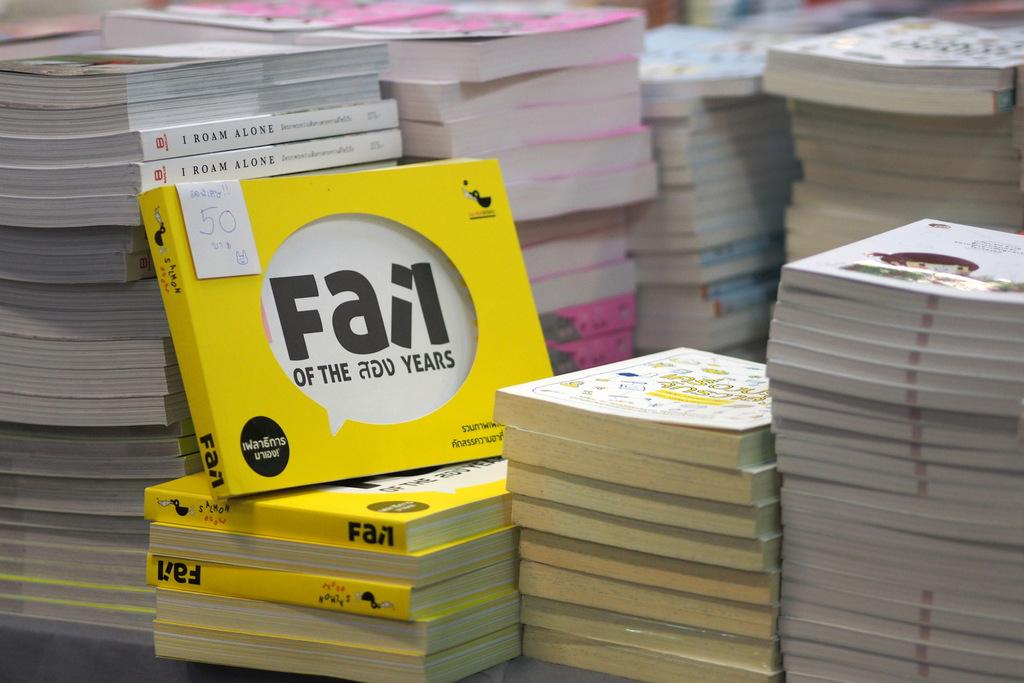<image>
Relay a brief, clear account of the picture shown. A book titled "Fail" sits among stacks of other books. 